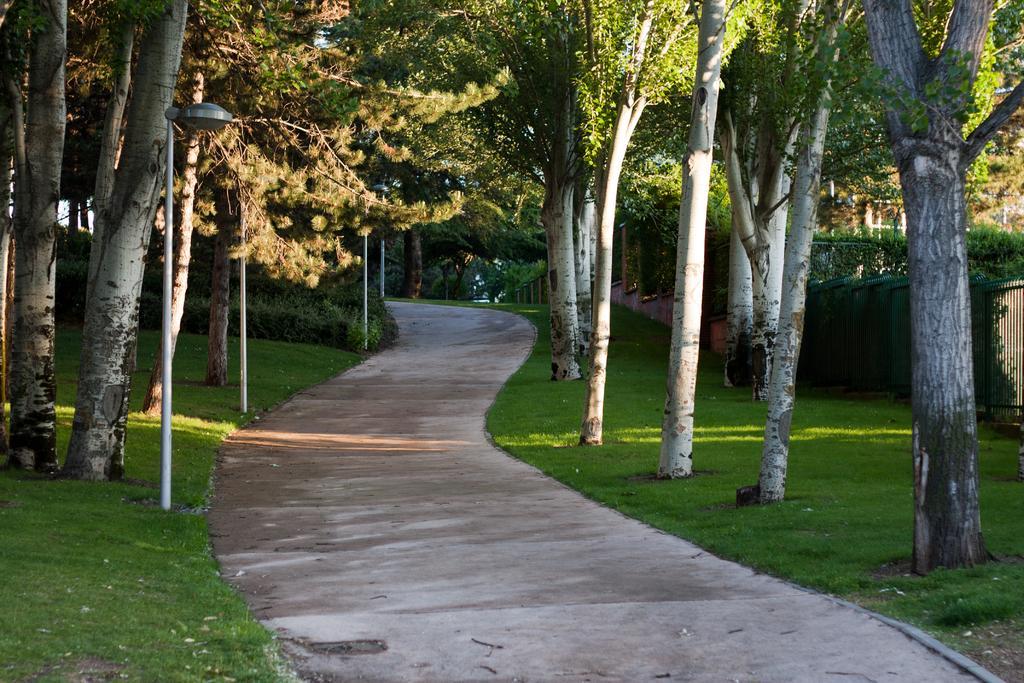How would you summarize this image in a sentence or two? In the middle of this image, there is a road. On both sides of this road, there are trees, plants and grass on the ground. On the left side, there is a light attached to a pole. In the background, there is a fence and there are trees. 